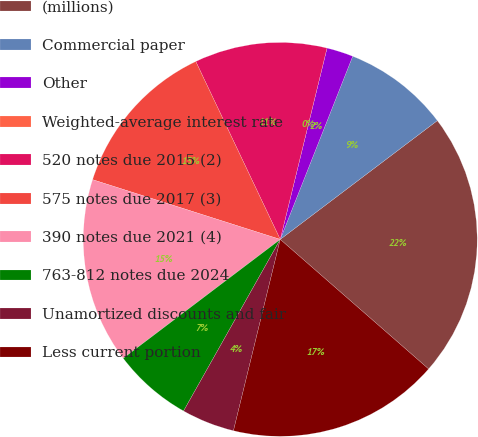Convert chart. <chart><loc_0><loc_0><loc_500><loc_500><pie_chart><fcel>(millions)<fcel>Commercial paper<fcel>Other<fcel>Weighted-average interest rate<fcel>520 notes due 2015 (2)<fcel>575 notes due 2017 (3)<fcel>390 notes due 2021 (4)<fcel>763-812 notes due 2024<fcel>Unamortized discounts and fair<fcel>Less current portion<nl><fcel>21.73%<fcel>8.7%<fcel>2.18%<fcel>0.0%<fcel>10.87%<fcel>13.04%<fcel>15.22%<fcel>6.52%<fcel>4.35%<fcel>17.39%<nl></chart> 